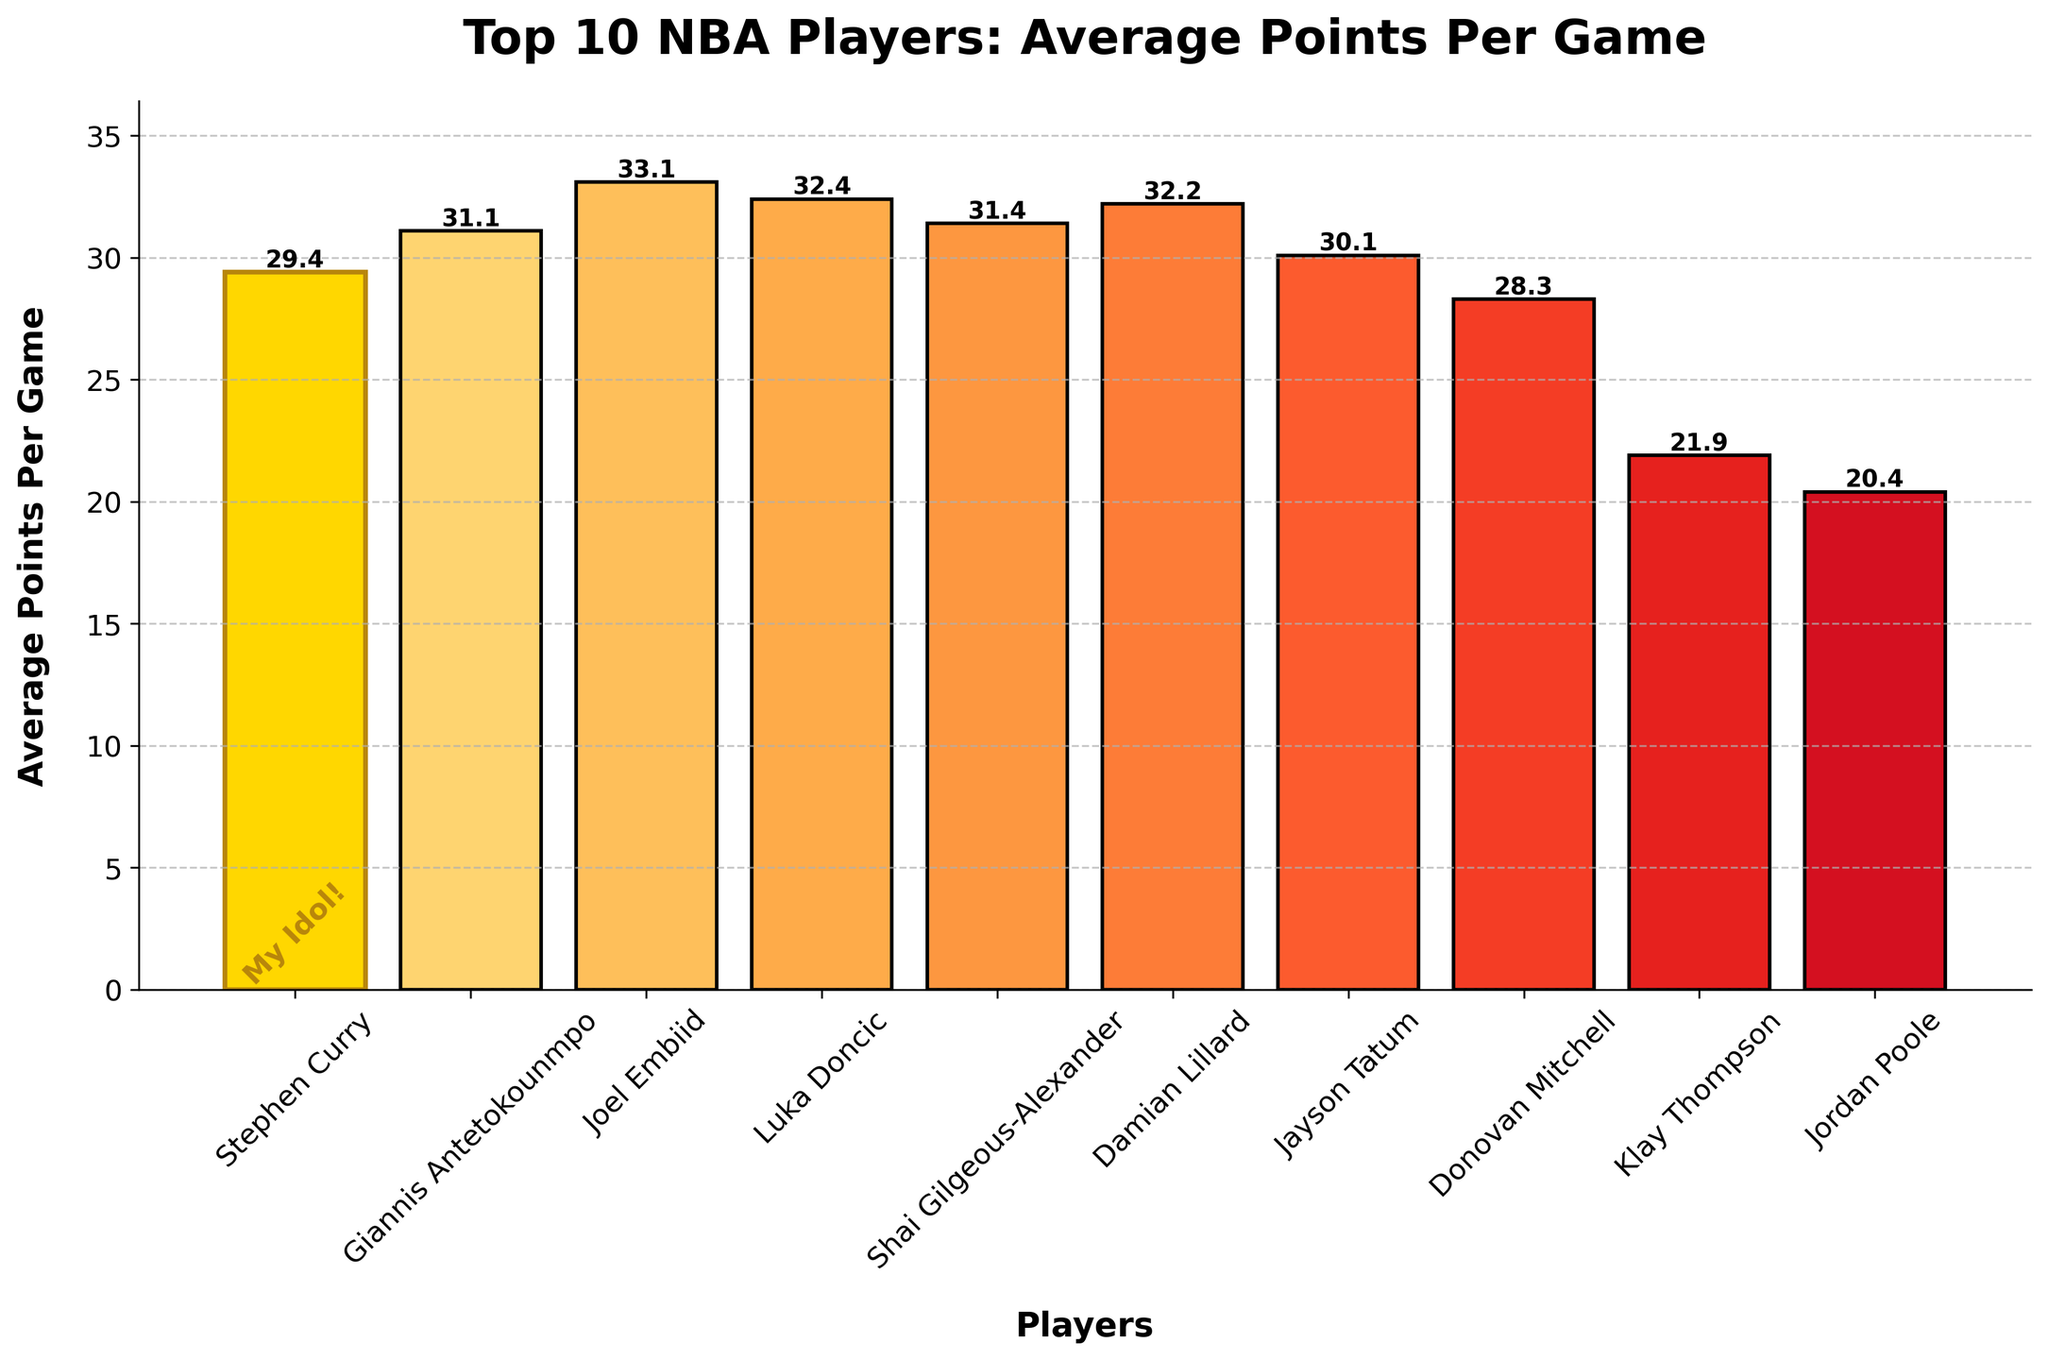Who scored the highest average points per game? To determine this, find the player with the tallest bar. Joel Embiid has the tallest bar.
Answer: Joel Embiid How many points does Stephen Curry score on average per game? Look at the bar corresponding to Stephen Curry and check its labeled height. The height is 29.4 points.
Answer: 29.4 Who are the three players with the lowest average points per game? Identify the three shortest bars. They belong to Klay Thompson, Jordan Poole, and Donovan Mitchell, in that order.
Answer: Klay Thompson, Jordan Poole, Donovan Mitchell What is the difference in average points per game between Joel Embiid and Stephen Curry? Look at the height of the bars for Joel Embiid and Stephen Curry and subtract Curry's value from Embiid's value. Joel Embiid: 33.1, Stephen Curry: 29.4. The difference is 33.1 - 29.4 = 3.7.
Answer: 3.7 Which player's bar is highlighted in gold? The player with the highlighted gold bar has special visual attributes like a different bar color and an additional text. This player is Stephen Curry.
Answer: Stephen Curry Who scores more on average, Luka Doncic or Damian Lillard, and by how much? Compare the heights of the respective bars. Luka Doncic: 32.4, Damian Lillard: 32.2. Luka Doncic scores more by 0.2 points.
Answer: Luka Doncic, 0.2 What is the average of the top 5 players' average points per game? Add the average points per game of the top 5 players and divide by 5. The top 5: Joel Embiid (33.1), Luka Doncic (32.4), Shai Gilgeous-Alexander (31.4), Giannis Antetokounmpo (31.1), Damian Lillard (32.2). Sum: 33.1 + 32.4 + 31.4 + 31.1 + 32.2 = 160.2. Average: 160.2 / 5 = 32.04.
Answer: 32.04 Is there another player who scores less than Klay Thompson on average? Compare Klay Thompson's bar with all others. The only shorter bar is Jordan Poole's, which is 20.4 versus Klay Thompson's 21.9.
Answer: Yes What’s the sum of average points per game of the Golden State Warriors players in the list? Add the average points per game of Stephen Curry, Klay Thompson, and Jordan Poole. Stephen Curry: 29.4, Klay Thompson: 21.9, Jordan Poole: 20.4. Sum: 29.4 + 21.9 + 20.4 = 71.7.
Answer: 71.7 Who has a higher average points per game, Jayson Tatum or Shai Gilgeous-Alexander? Compare the heights of their respective bars. Jayson Tatum has 30.1, whereas Shai Gilgeous-Alexander has 31.4. Shai Gilgeous-Alexander scores higher.
Answer: Shai Gilgeous-Alexander 